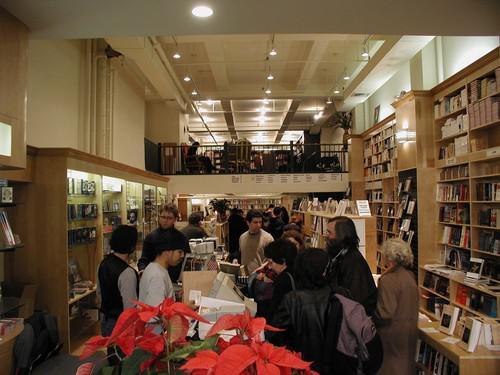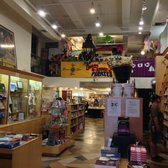The first image is the image on the left, the second image is the image on the right. Analyze the images presented: Is the assertion "An image shows the interior of a bookstore, with cluster of shoppers not behind glass." valid? Answer yes or no. Yes. The first image is the image on the left, the second image is the image on the right. Given the left and right images, does the statement "There are no people in the image on the left" hold true? Answer yes or no. No. 